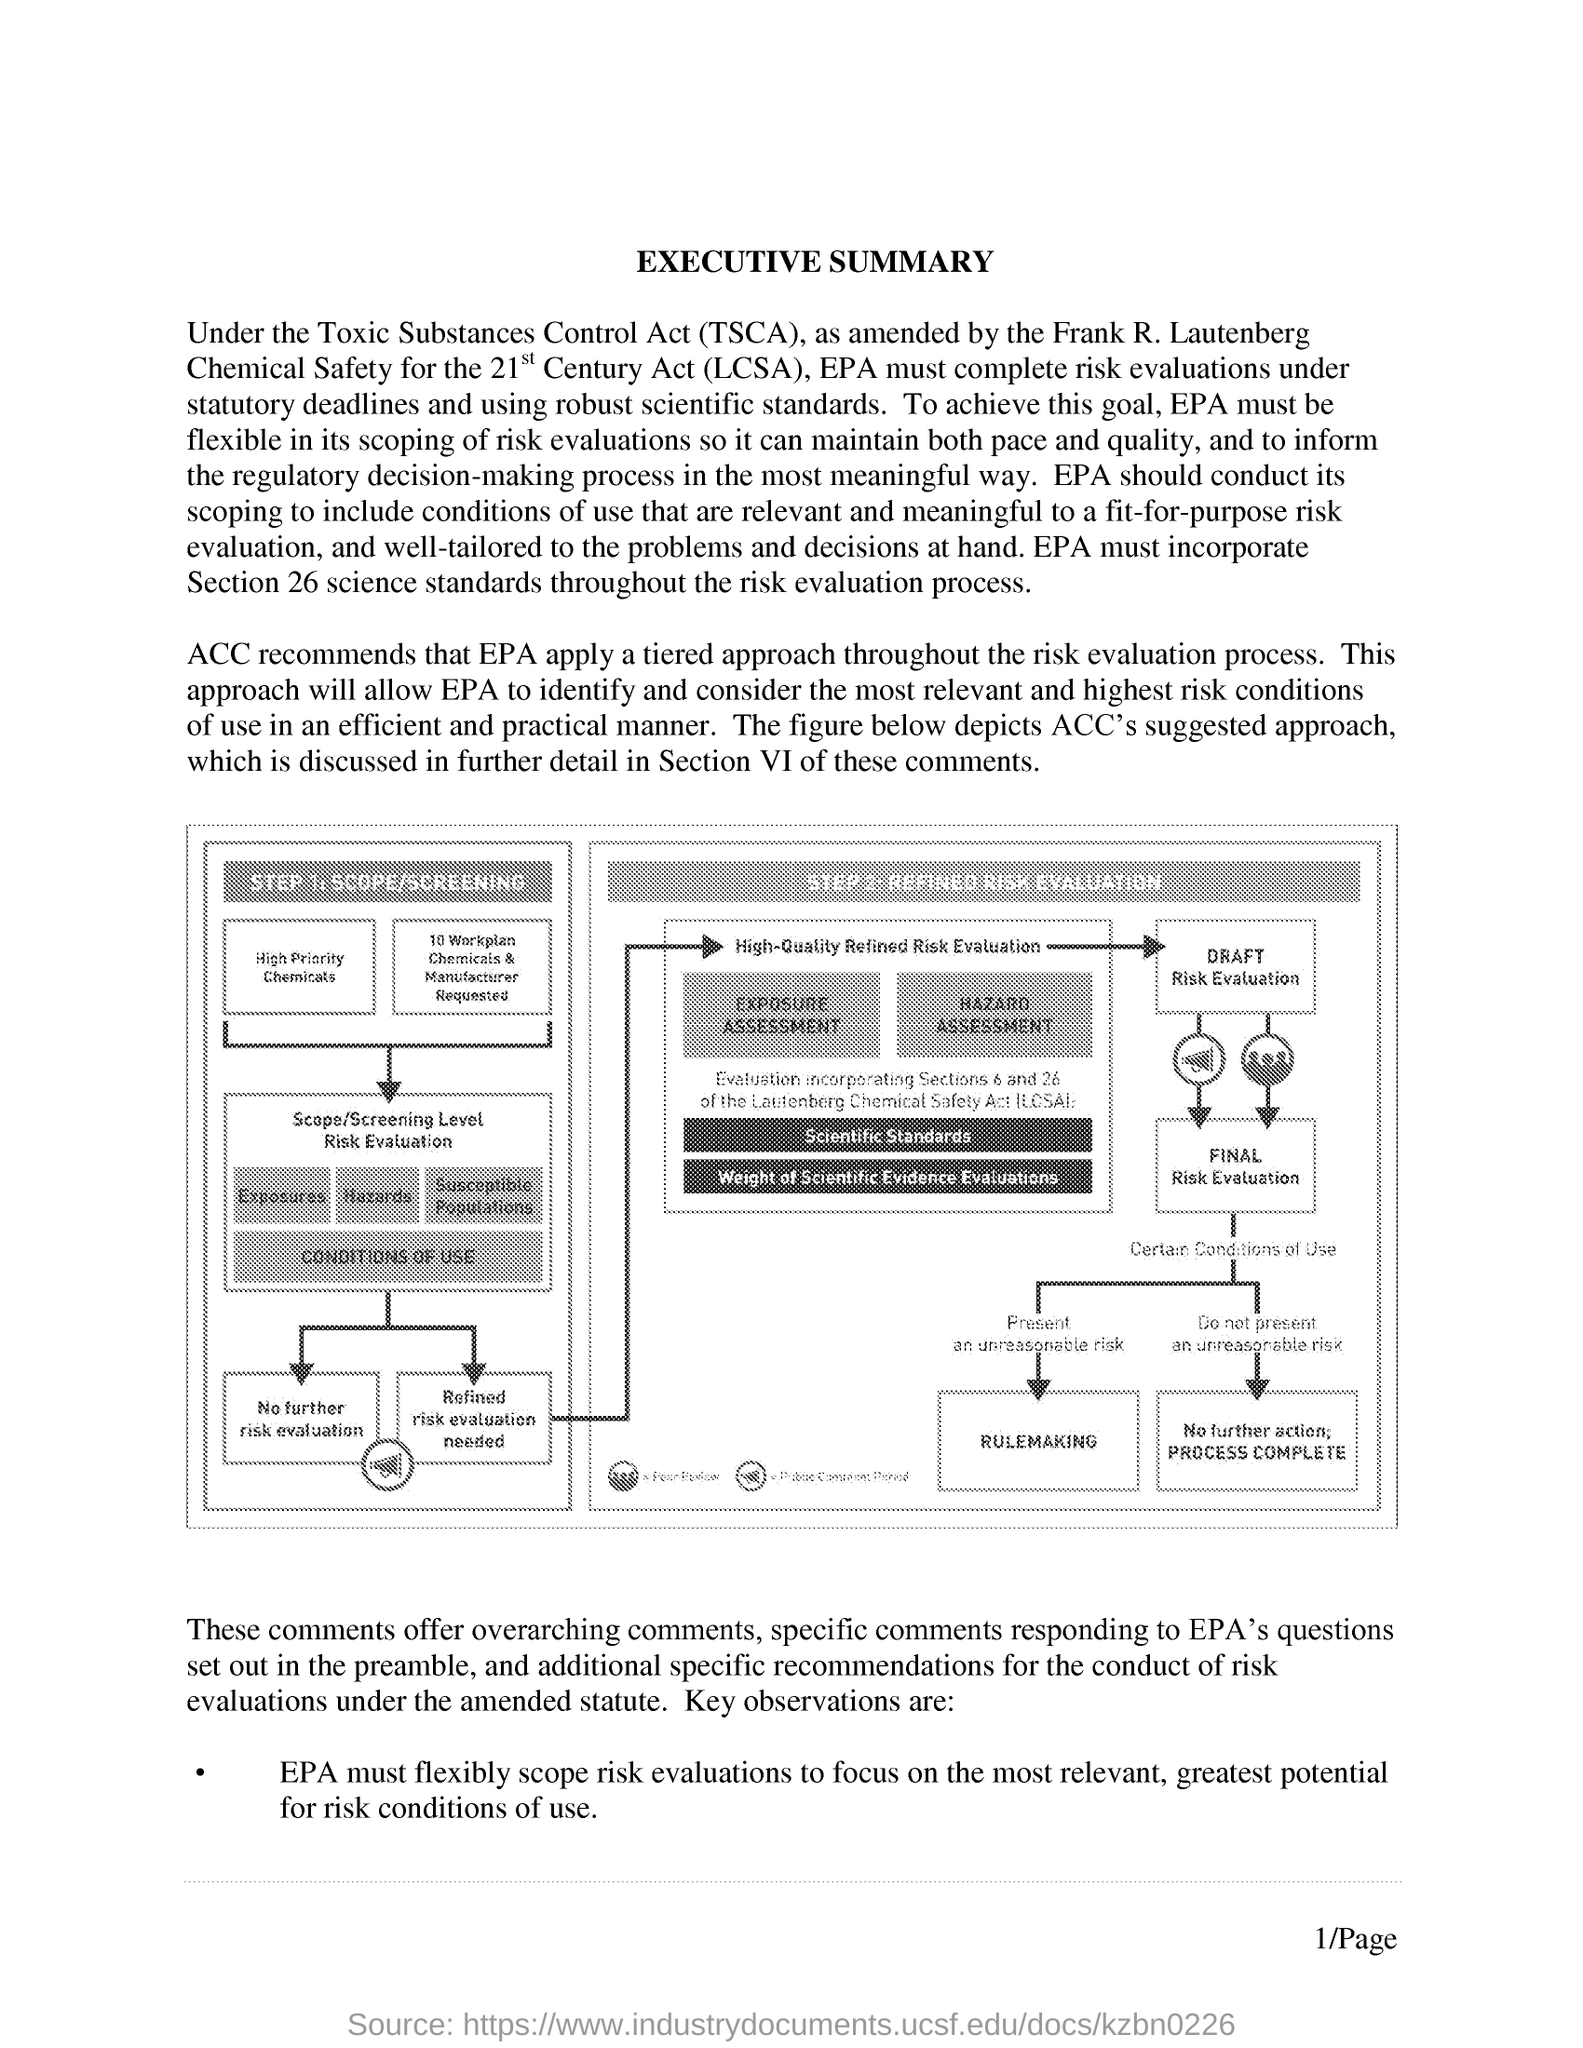What is the heading of the document?
Provide a short and direct response. Executive Summary. What is STEP 1 in the diagram?
Your response must be concise. Scope/Screening. What is the full form of TSCA?
Make the answer very short. Toxic Substances Control Act. 